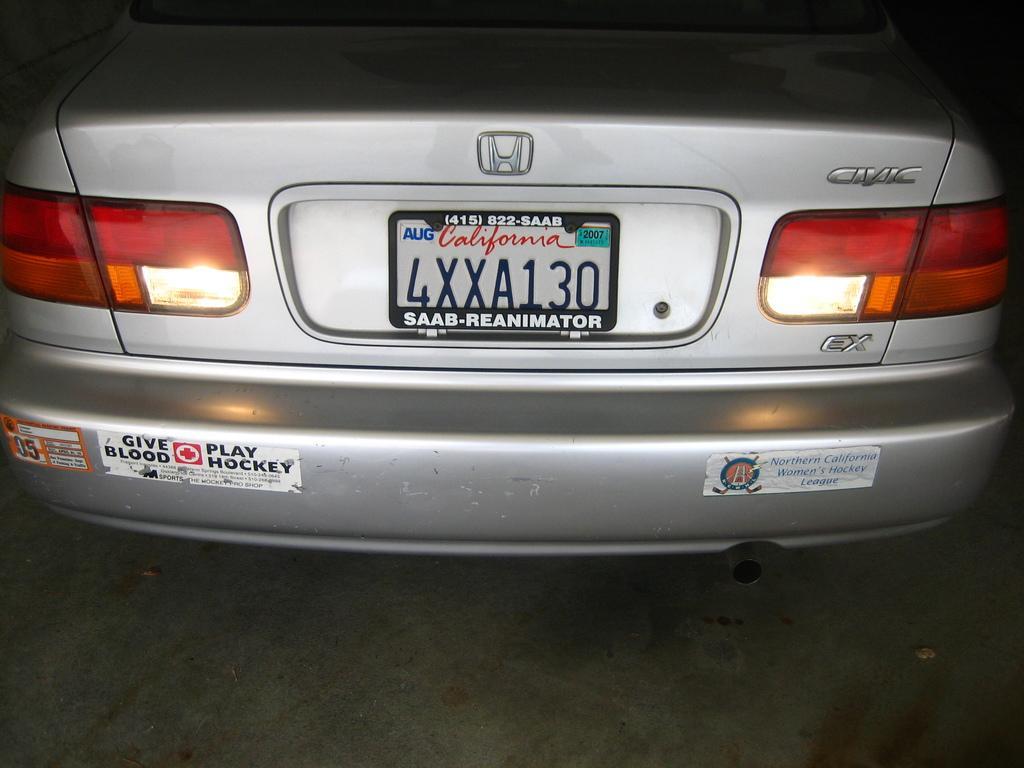How would you summarize this image in a sentence or two? In this image we can see there is a vehicle with the registration number plate and some text written on it. 